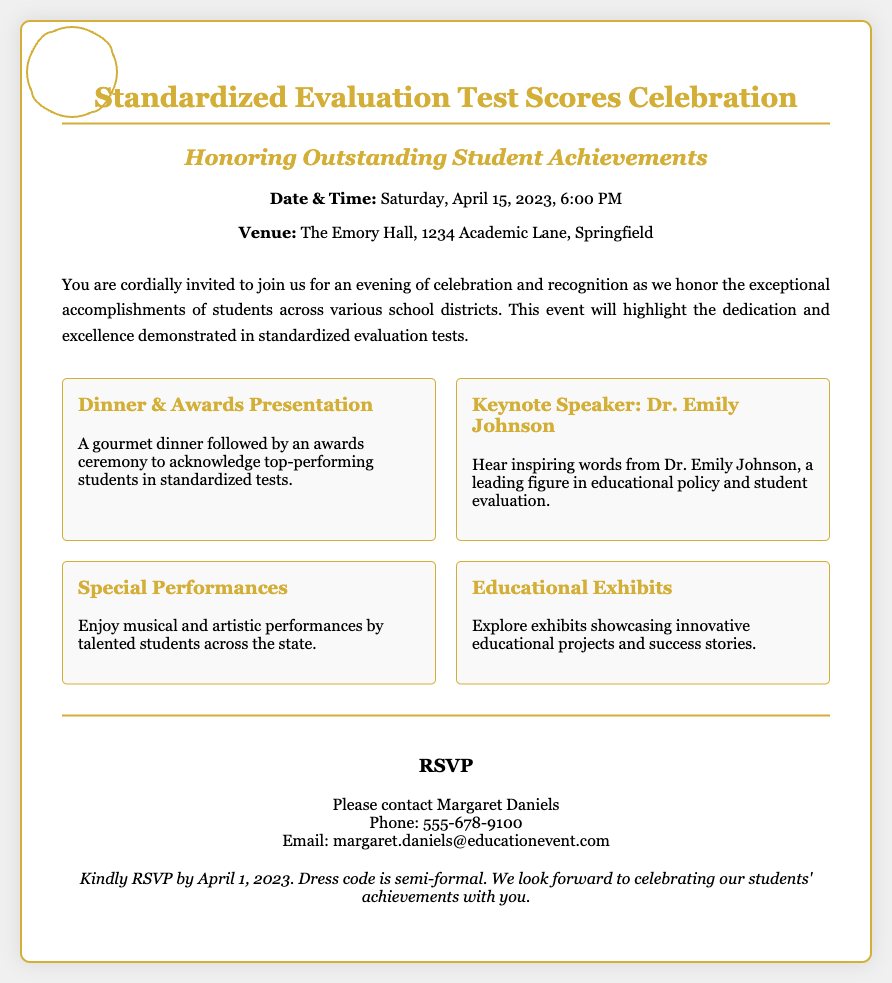what is the date of the event? The date of the event is specified in the details section of the invitation.
Answer: Saturday, April 15, 2023 what is the venue for the celebration? The venue is stated in the details section of the invitation.
Answer: The Emory Hall, 1234 Academic Lane, Springfield who is the keynote speaker? The keynote speaker is mentioned in the features section of the invitation.
Answer: Dr. Emily Johnson what kind of performances will be featured? This information is found in the features section of the invitation.
Answer: Musical and artistic performances what is the RSVP deadline? The RSVP deadline is mentioned in the additional notes of the invitation.
Answer: April 1, 2023 what is the dress code for the event? The dress code is specified in the additional notes of the invitation.
Answer: Semi-formal how many features are highlighted in the invitation? The number of features is based on the features section of the invitation, which lists them.
Answer: Four what will follow the gourmet dinner? This follows logically from the sequence provided in the features section.
Answer: Awards presentation who should be contacted for RSVP? The contact person for RSVP is provided in the RSVP section.
Answer: Margaret Daniels 